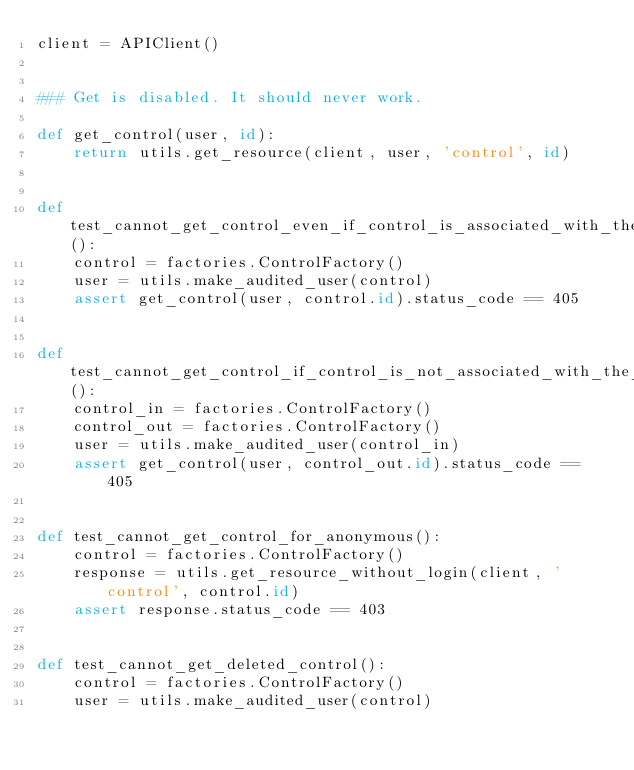<code> <loc_0><loc_0><loc_500><loc_500><_Python_>client = APIClient()


### Get is disabled. It should never work.

def get_control(user, id):
    return utils.get_resource(client, user, 'control', id)


def test_cannot_get_control_even_if_control_is_associated_with_the_user():
    control = factories.ControlFactory()
    user = utils.make_audited_user(control)
    assert get_control(user, control.id).status_code == 405


def test_cannot_get_control_if_control_is_not_associated_with_the_user():
    control_in = factories.ControlFactory()
    control_out = factories.ControlFactory()
    user = utils.make_audited_user(control_in)
    assert get_control(user, control_out.id).status_code == 405


def test_cannot_get_control_for_anonymous():
    control = factories.ControlFactory()
    response = utils.get_resource_without_login(client, 'control', control.id)
    assert response.status_code == 403


def test_cannot_get_deleted_control():
    control = factories.ControlFactory()
    user = utils.make_audited_user(control)</code> 